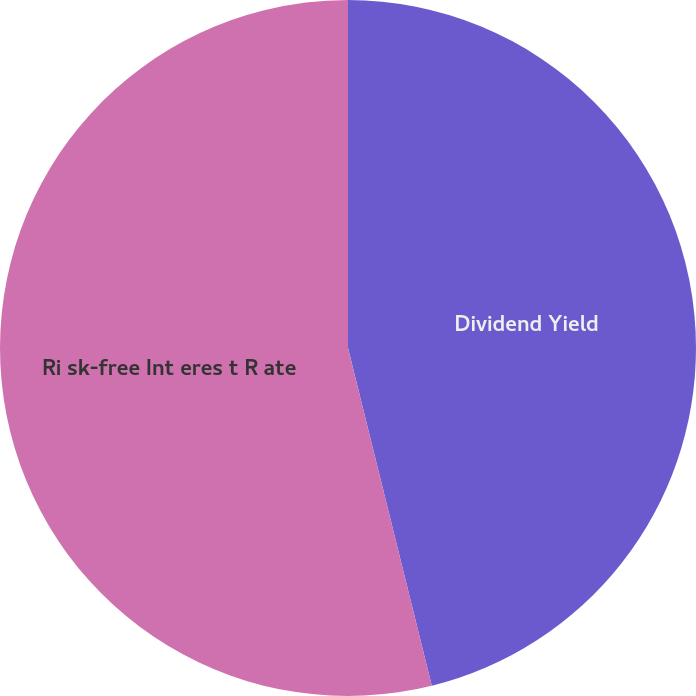Convert chart. <chart><loc_0><loc_0><loc_500><loc_500><pie_chart><fcel>Dividend Yield<fcel>Ri sk-free Int eres t R ate<nl><fcel>46.13%<fcel>53.87%<nl></chart> 